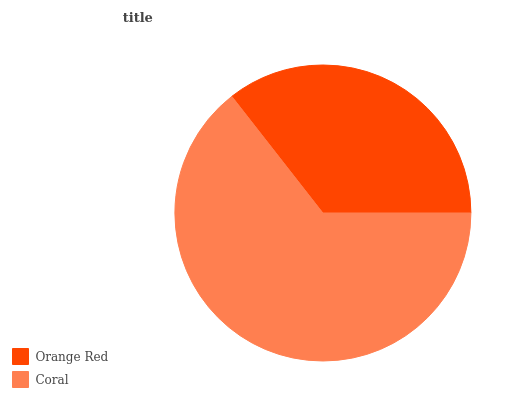Is Orange Red the minimum?
Answer yes or no. Yes. Is Coral the maximum?
Answer yes or no. Yes. Is Coral the minimum?
Answer yes or no. No. Is Coral greater than Orange Red?
Answer yes or no. Yes. Is Orange Red less than Coral?
Answer yes or no. Yes. Is Orange Red greater than Coral?
Answer yes or no. No. Is Coral less than Orange Red?
Answer yes or no. No. Is Coral the high median?
Answer yes or no. Yes. Is Orange Red the low median?
Answer yes or no. Yes. Is Orange Red the high median?
Answer yes or no. No. Is Coral the low median?
Answer yes or no. No. 